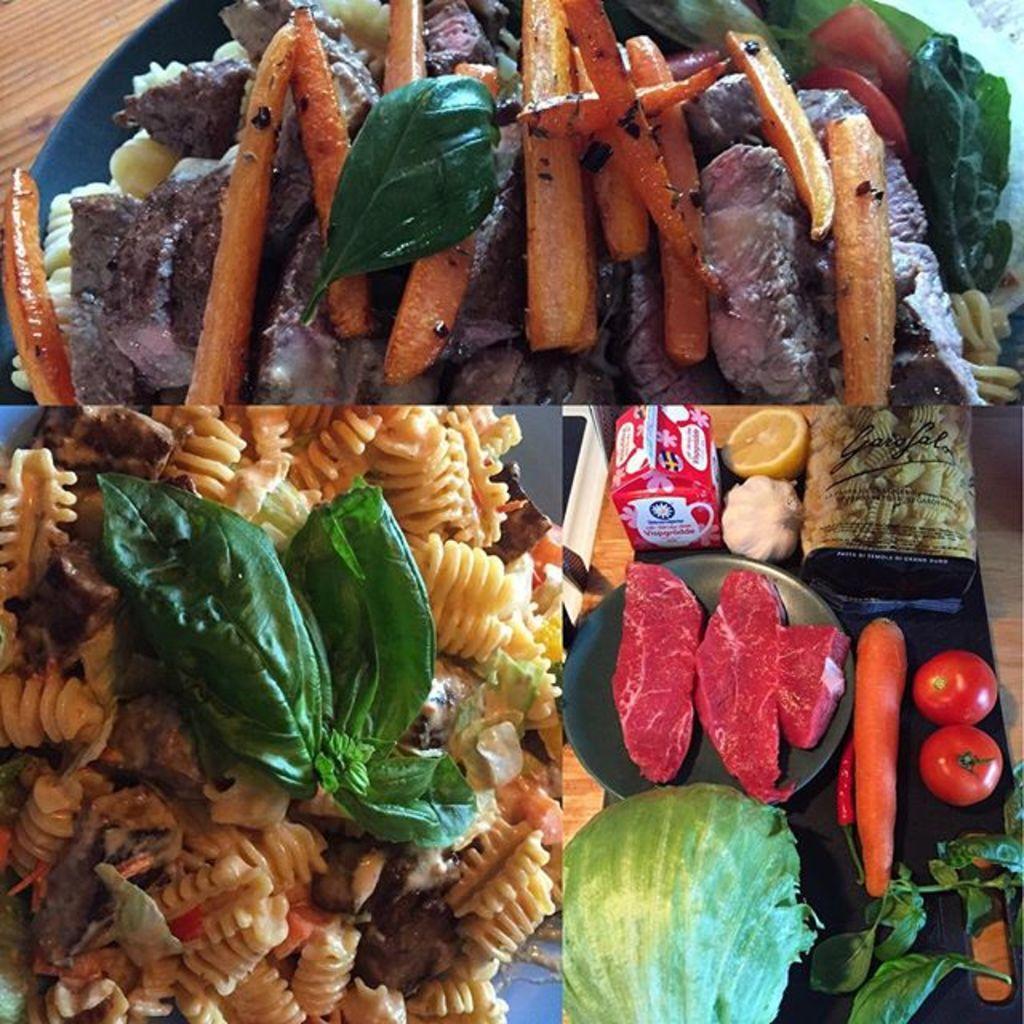Describe this image in one or two sentences. This is a collage image. We can see some food items. In the first part of the image, we can see some food item in a container is placed on the surface. In the second part of the image, we can see some food items. In the third part of the image, we can see some food items and objects like a carrot, tomatoes and some leaves are placed on the surface. 